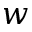<formula> <loc_0><loc_0><loc_500><loc_500>w</formula> 